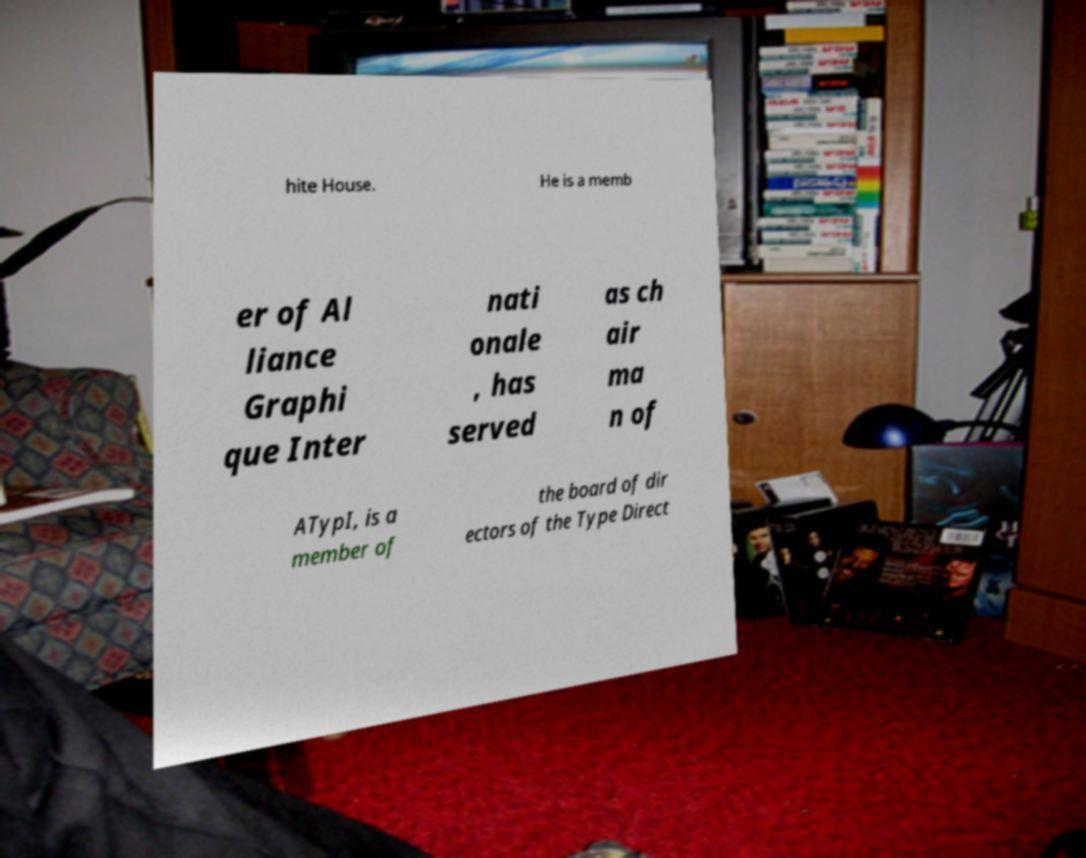For documentation purposes, I need the text within this image transcribed. Could you provide that? hite House. He is a memb er of Al liance Graphi que Inter nati onale , has served as ch air ma n of ATypI, is a member of the board of dir ectors of the Type Direct 